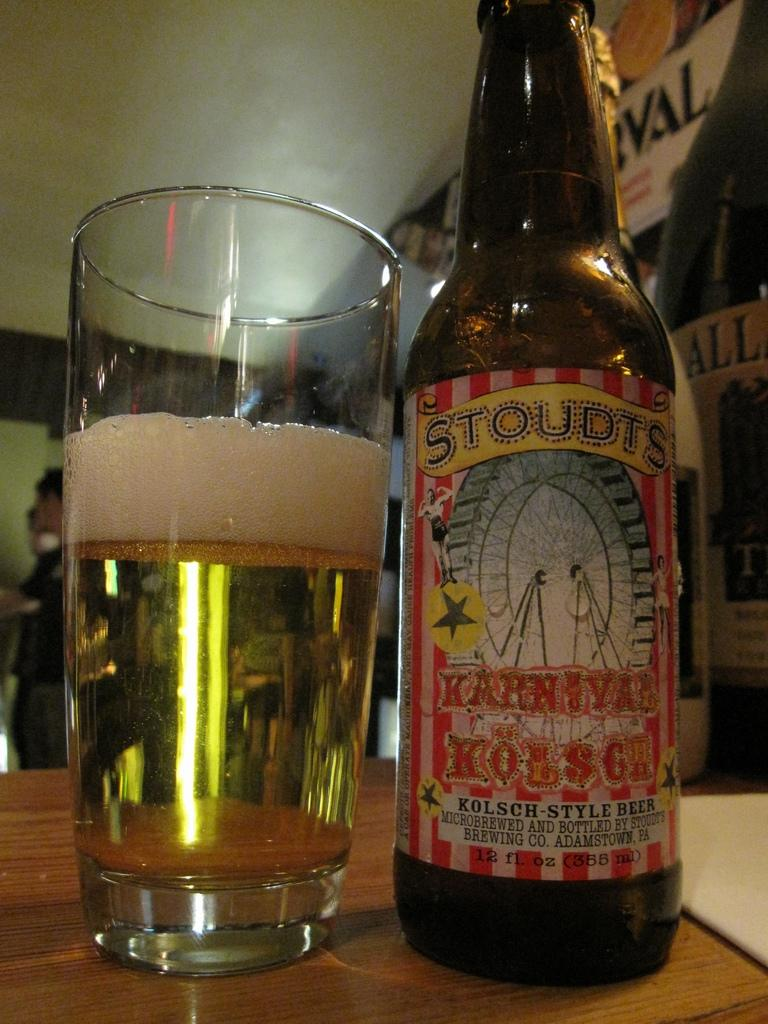<image>
Write a terse but informative summary of the picture. A bottle of Stoudts Karnival Kolsch next to a glass of beer. 